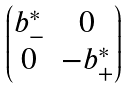Convert formula to latex. <formula><loc_0><loc_0><loc_500><loc_500>\begin{pmatrix} b ^ { * } _ { - } & 0 \\ 0 & - b ^ { * } _ { + } \end{pmatrix}</formula> 